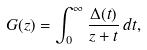Convert formula to latex. <formula><loc_0><loc_0><loc_500><loc_500>G ( z ) = \int _ { 0 } ^ { \infty } \frac { \Delta ( t ) } { z + t } \, d t ,</formula> 